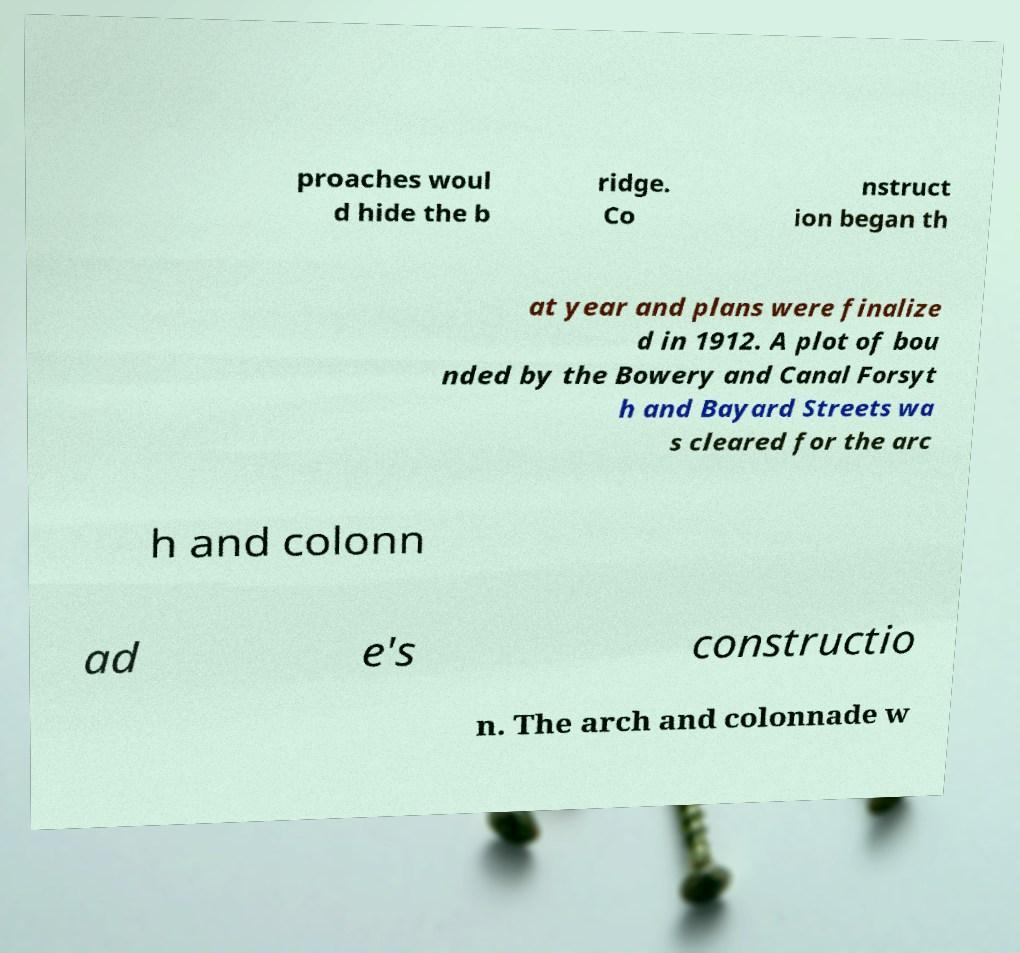For documentation purposes, I need the text within this image transcribed. Could you provide that? proaches woul d hide the b ridge. Co nstruct ion began th at year and plans were finalize d in 1912. A plot of bou nded by the Bowery and Canal Forsyt h and Bayard Streets wa s cleared for the arc h and colonn ad e's constructio n. The arch and colonnade w 